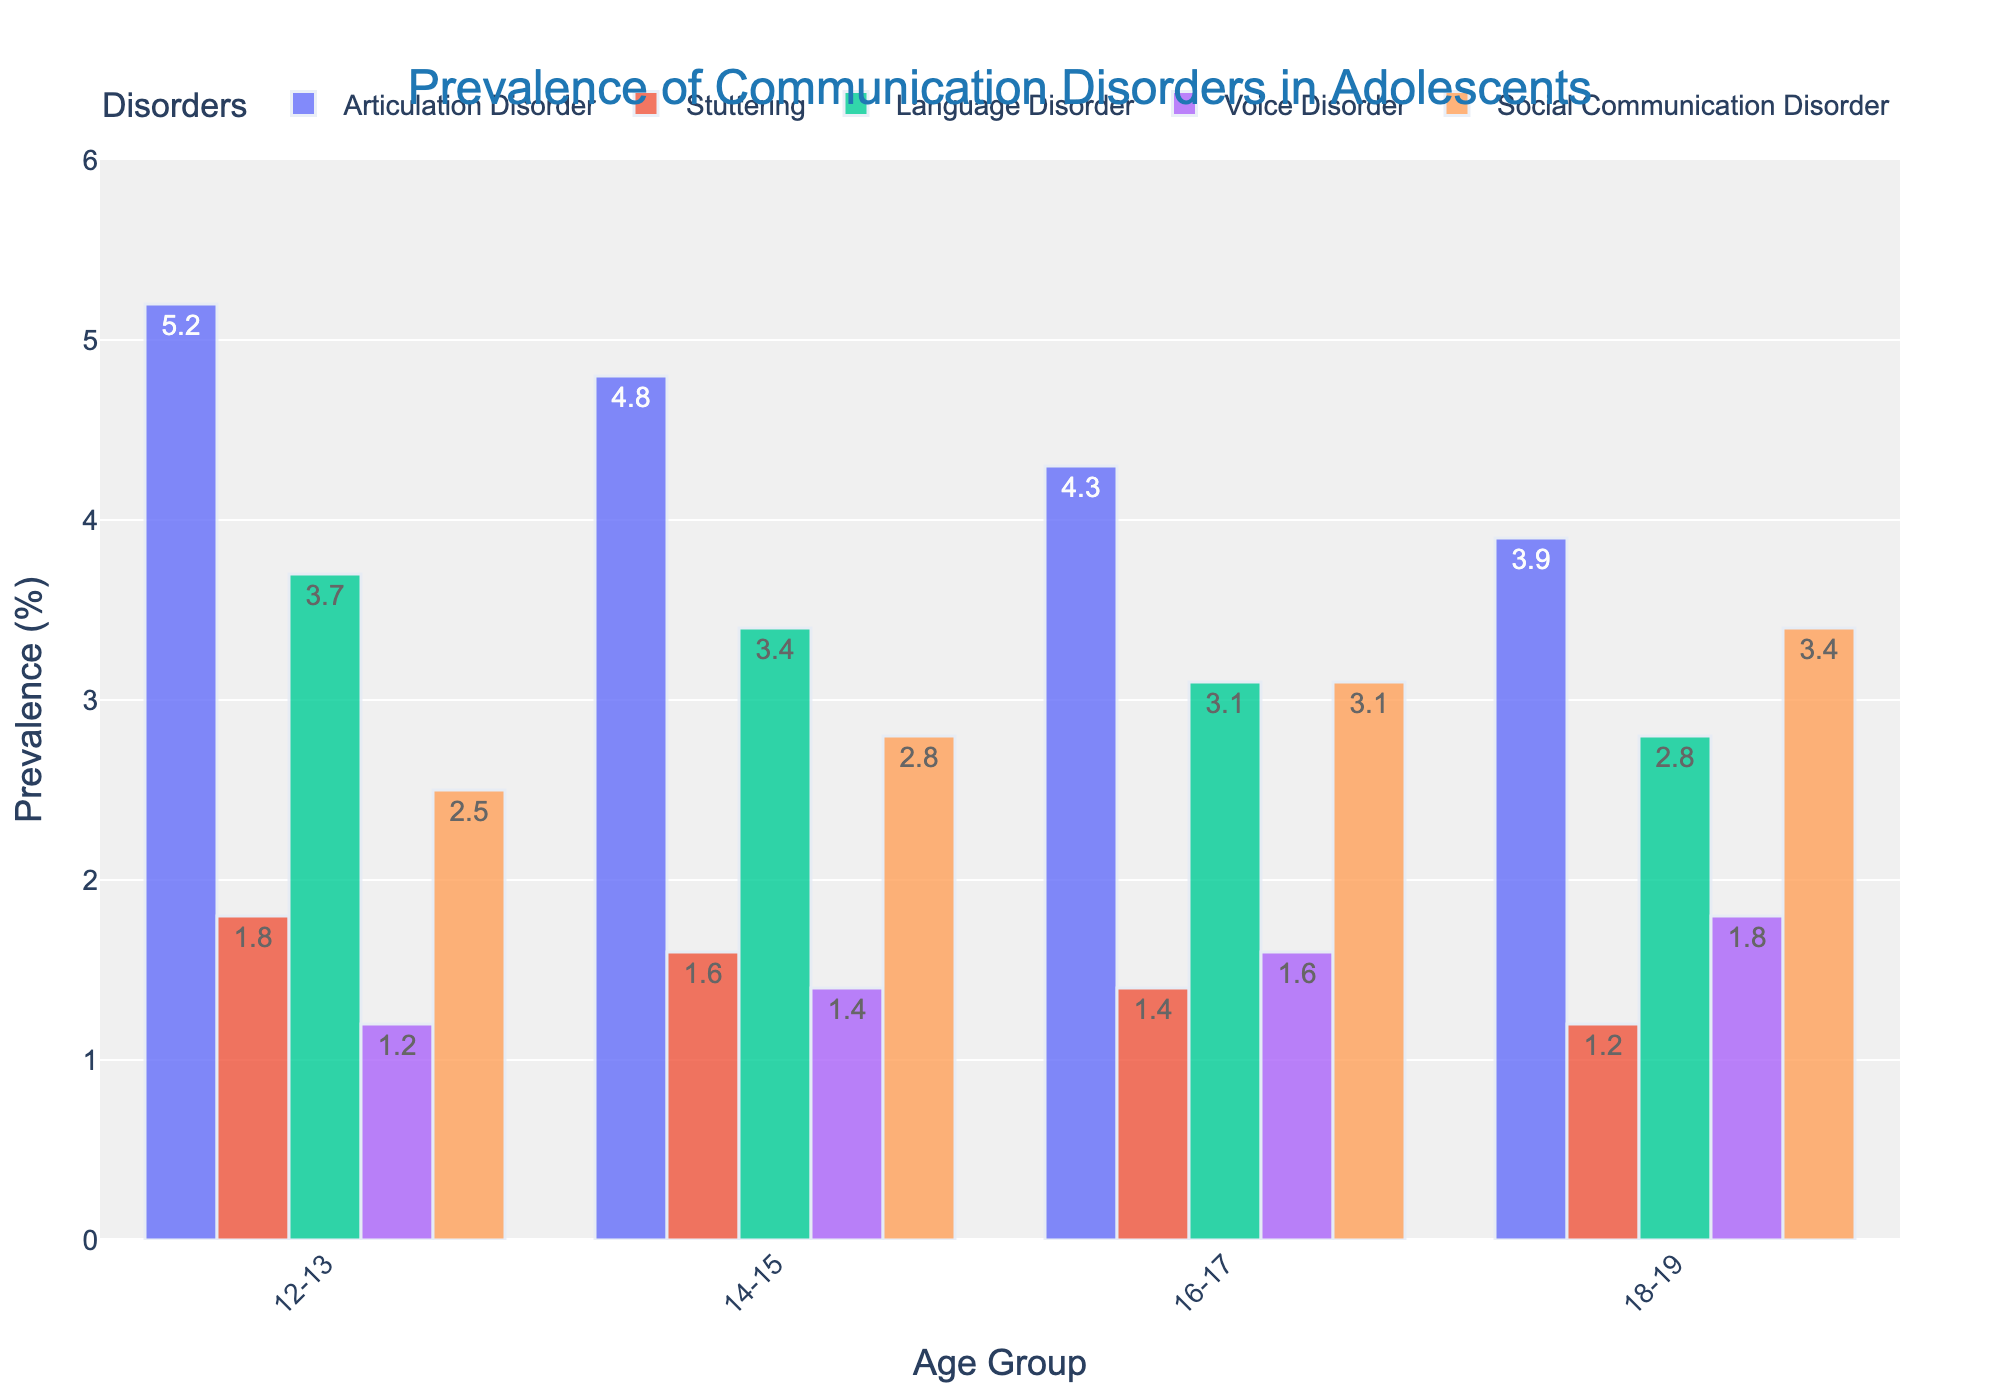What is the prevalence rate of the language disorder amongst 14-15-year-olds? Locate the data bar for the language disorder in the 14-15 age group and refer to the value indicated within that bar.
Answer: 3.4 Which age group has the highest prevalence of stuttering? Compare the heights or values of the stuttering bars across all age groups. The tallest bar will correspond to the group with the highest prevalence.
Answer: 12-13 What is the difference in the prevalence of social communication disorder between 12-13 year-olds and 18-19 year-olds? Look for the prevalence values of social communication disorder in the 12-13 age group (2.5) and the 18-19 age group (3.4). Subtract the former from the latter.
Answer: 0.9 Which disorder has the lowest prevalence rate in all age groups? Compare the shortest bars across all disorders in each age group. The disorder represented by the shortest bars consistently will have the lowest prevalence rate.
Answer: Voice Disorder What is the total prevalence of articulation disorder across all age groups? Sum the prevalence rates of the articulation disorder in all age groups: 5.2 (12-13) + 4.8 (14-15) + 4.3 (16-17) + 3.9 (18-19).
Answer: 18.2 How does the prevalence of voice disorder change as age increases from 12-13 to 18-19 years? Observe the trend by noting the values of voice disorder in each age group sequentially (12-13: 1.2, 14-15: 1.4, 16-17: 1.6, 18-19: 1.8).
Answer: It increases Which disorder shows a consistent increase in prevalence as the age group progresses? Analyze the bars representing each disorder for consistent upward trends from one age group to the next.
Answer: Social Communication Disorder What is the average prevalence of stuttering across all age groups? Sum the prevalence rates of stuttering in all age groups and divide by the number of groups (1.8 + 1.6 + 1.4 + 1.2)/4.
Answer: 1.5 In which age group is the difference between language and articulation disorder prevalence the largest? Calculate the differences for each age group: 12-13: (5.2-3.7), 14-15: (4.8-3.4), 16-17: (4.3-3.1), 18-19: (3.9-2.8). Identify the group with the largest difference.
Answer: 12-13 Which age group has the highest combined prevalence of communication disorders (sum of all disorders)? Calculate the sum of prevalence rates for each age group and compare: 12-13: (5.2+1.8+3.7+1.2+2.5), 14-15: (4.8+1.6+3.4+1.4+2.8), 16-17: (4.3+1.4+3.1+1.6+3.1), 18-19: (3.9+1.2+2.8+1.8+3.4).
Answer: 12-13 